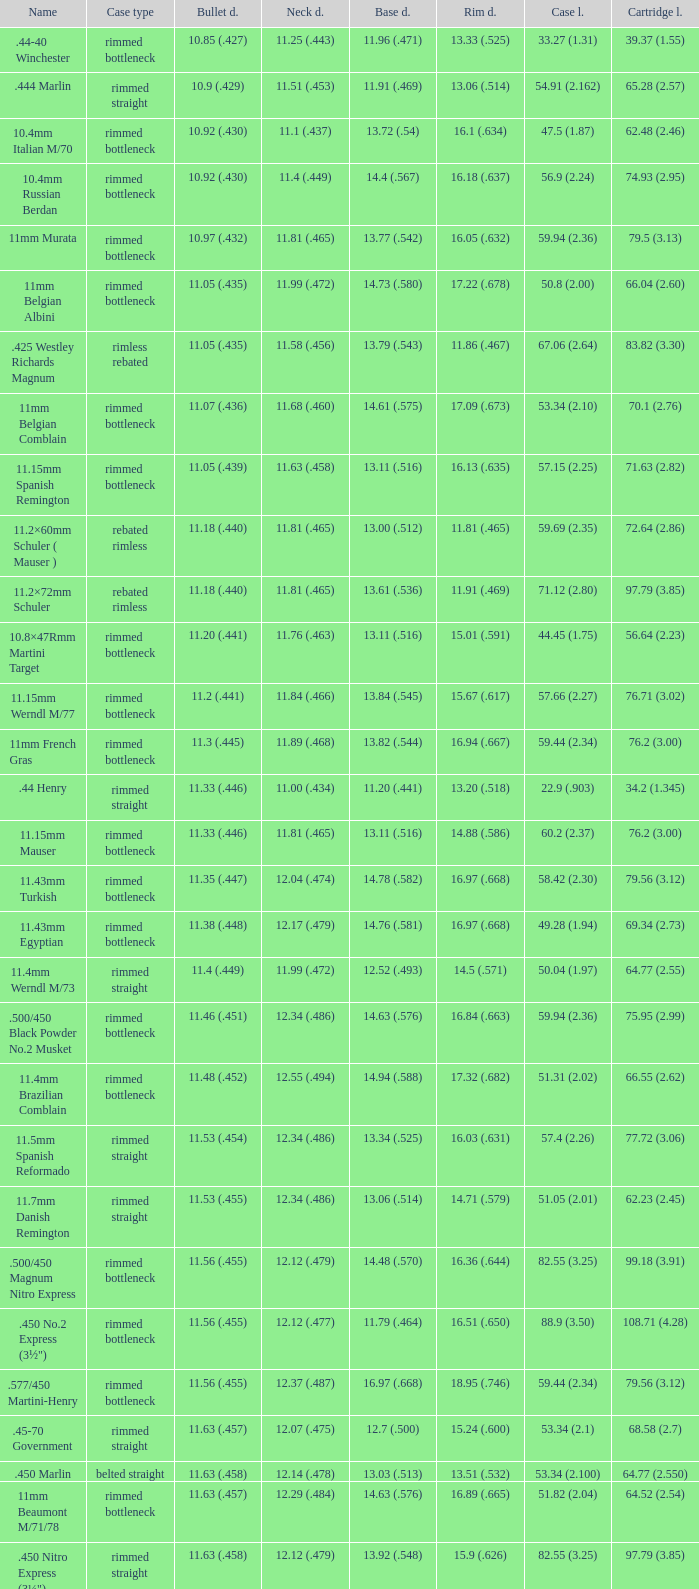Which Case type has a Cartridge length of 64.77 (2.550)? Belted straight. 